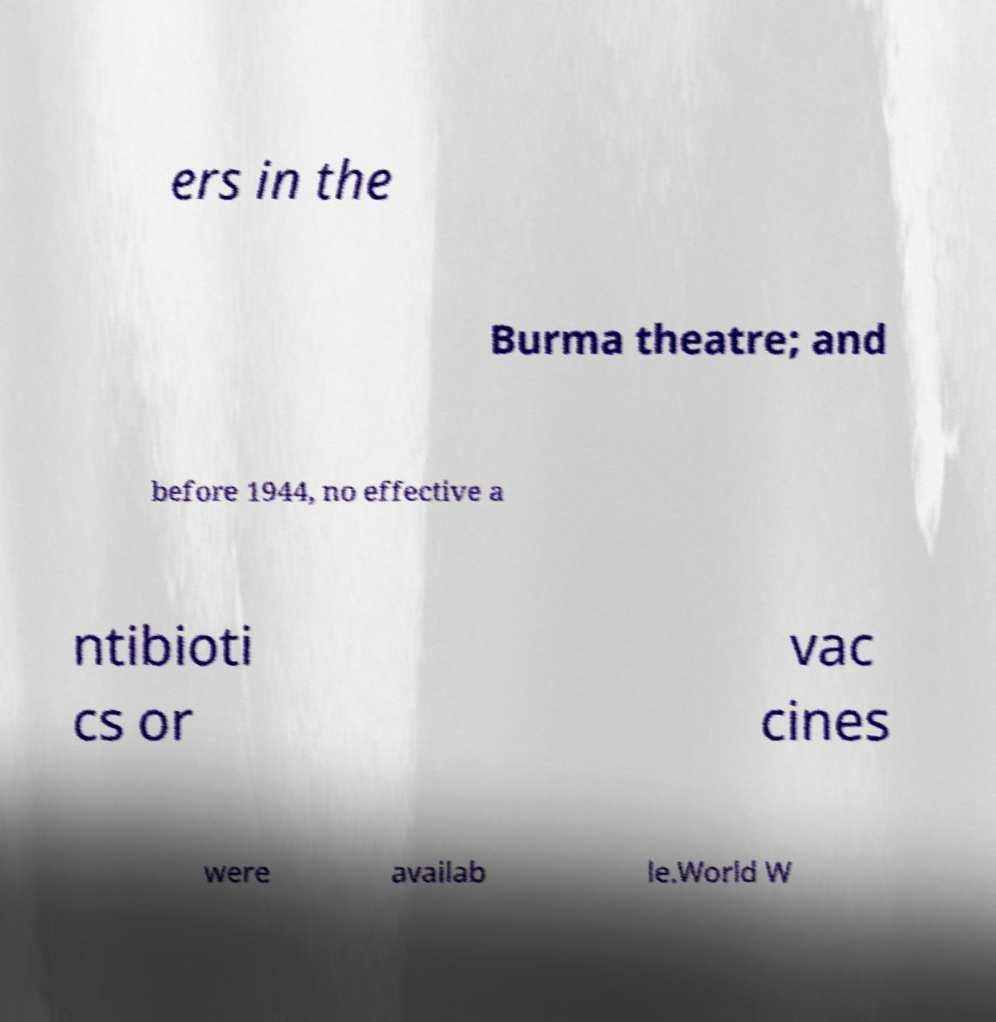There's text embedded in this image that I need extracted. Can you transcribe it verbatim? ers in the Burma theatre; and before 1944, no effective a ntibioti cs or vac cines were availab le.World W 